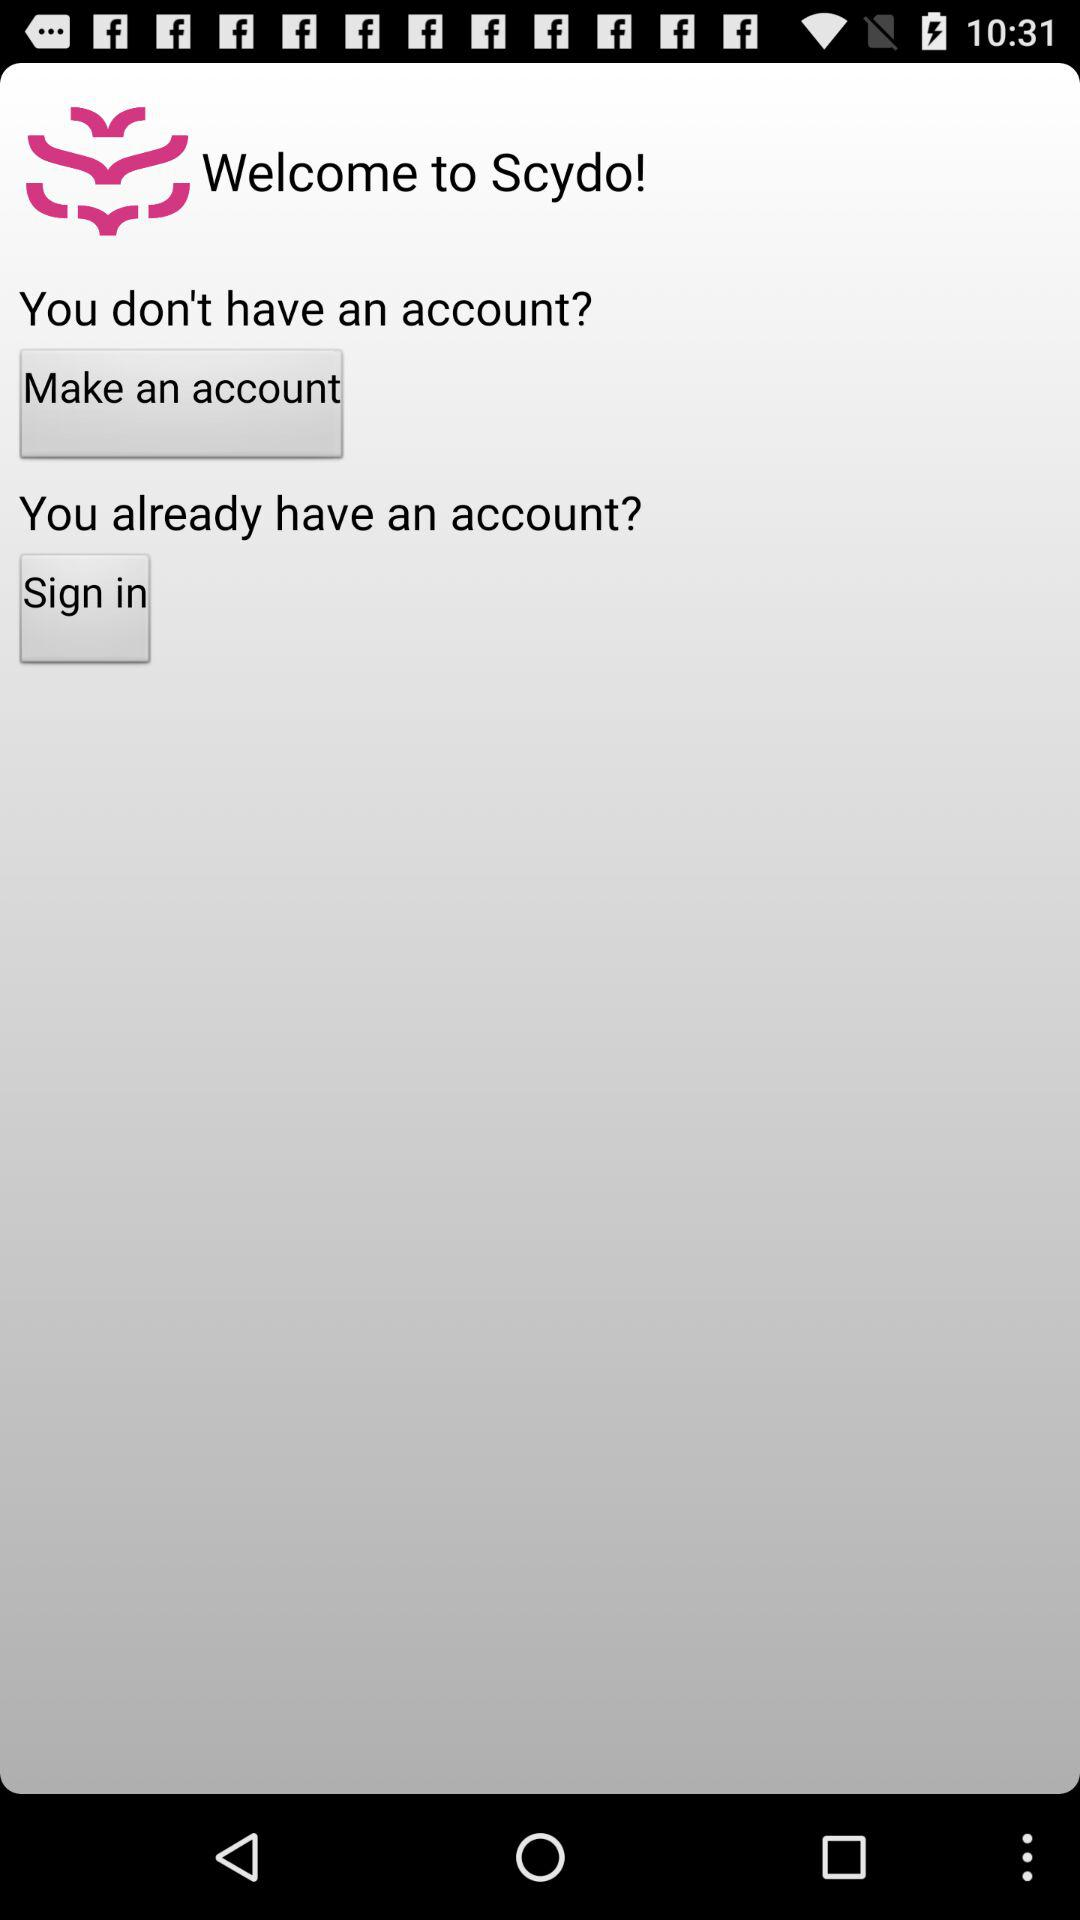Who is making the account?
When the provided information is insufficient, respond with <no answer>. <no answer> 